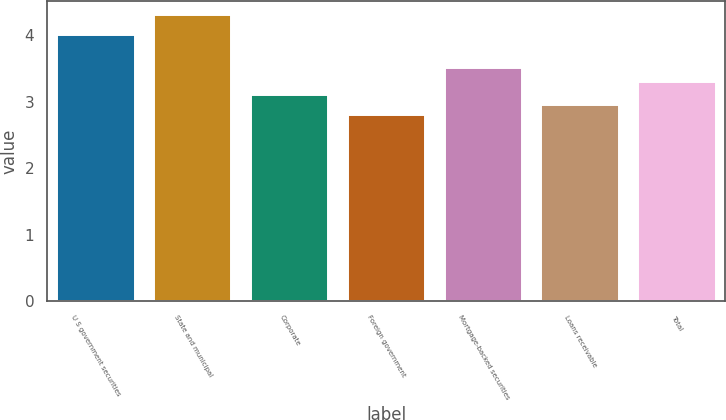<chart> <loc_0><loc_0><loc_500><loc_500><bar_chart><fcel>U S government securities<fcel>State and municipal<fcel>Corporate<fcel>Foreign government<fcel>Mortgage-backed securities<fcel>Loans receivable<fcel>Total<nl><fcel>4<fcel>4.3<fcel>3.1<fcel>2.8<fcel>3.5<fcel>2.95<fcel>3.3<nl></chart> 